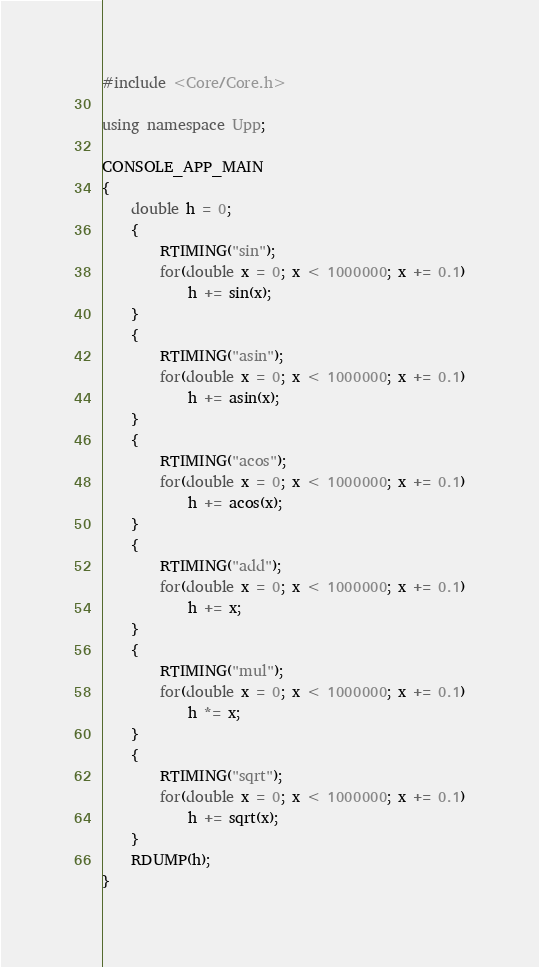Convert code to text. <code><loc_0><loc_0><loc_500><loc_500><_C++_>#include <Core/Core.h>

using namespace Upp;

CONSOLE_APP_MAIN
{
	double h = 0;
	{
		RTIMING("sin");
		for(double x = 0; x < 1000000; x += 0.1)
			h += sin(x);
	}
	{
		RTIMING("asin");
		for(double x = 0; x < 1000000; x += 0.1)
			h += asin(x);
	}
	{
		RTIMING("acos");
		for(double x = 0; x < 1000000; x += 0.1)
			h += acos(x);
	}
	{
		RTIMING("add");
		for(double x = 0; x < 1000000; x += 0.1)
			h += x;
	}
	{
		RTIMING("mul");
		for(double x = 0; x < 1000000; x += 0.1)
			h *= x;
	}
	{
		RTIMING("sqrt");
		for(double x = 0; x < 1000000; x += 0.1)
			h += sqrt(x);
	}
	RDUMP(h);
}

</code> 